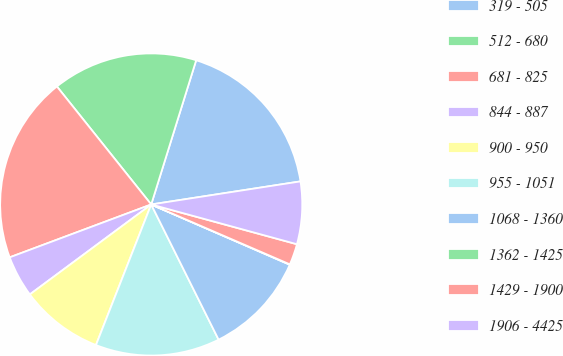Convert chart. <chart><loc_0><loc_0><loc_500><loc_500><pie_chart><fcel>319 - 505<fcel>512 - 680<fcel>681 - 825<fcel>844 - 887<fcel>900 - 950<fcel>955 - 1051<fcel>1068 - 1360<fcel>1362 - 1425<fcel>1429 - 1900<fcel>1906 - 4425<nl><fcel>17.75%<fcel>15.54%<fcel>19.96%<fcel>4.46%<fcel>8.89%<fcel>13.32%<fcel>11.11%<fcel>0.04%<fcel>2.25%<fcel>6.68%<nl></chart> 